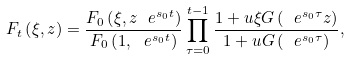<formula> <loc_0><loc_0><loc_500><loc_500>F _ { t } \left ( \xi , z \right ) = \frac { F _ { 0 } \left ( \xi , z \ e ^ { s _ { 0 } t } \right ) } { F _ { 0 } \left ( 1 , \ e ^ { s _ { 0 } t } \right ) } \prod _ { \tau = 0 } ^ { t - 1 } \frac { 1 + u \xi G \left ( \ e ^ { s _ { 0 } \tau } z \right ) } { 1 + u G \left ( \ e ^ { s _ { 0 } \tau } \right ) } ,</formula> 